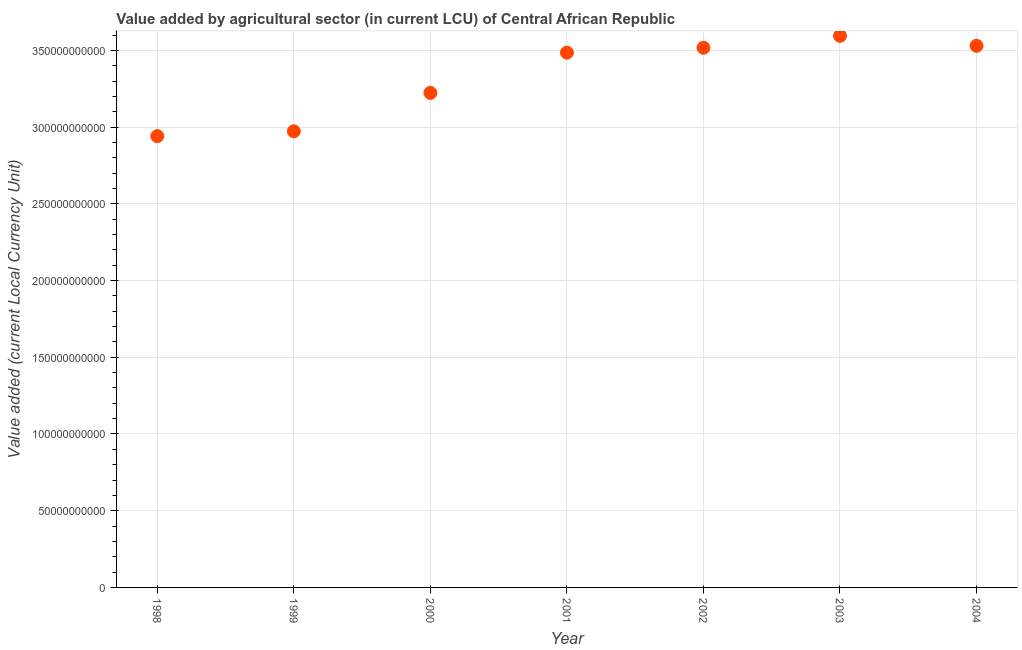What is the value added by agriculture sector in 1998?
Your answer should be compact. 2.94e+11. Across all years, what is the maximum value added by agriculture sector?
Ensure brevity in your answer.  3.59e+11. Across all years, what is the minimum value added by agriculture sector?
Your answer should be very brief. 2.94e+11. In which year was the value added by agriculture sector maximum?
Make the answer very short. 2003. What is the sum of the value added by agriculture sector?
Keep it short and to the point. 2.33e+12. What is the difference between the value added by agriculture sector in 2002 and 2003?
Ensure brevity in your answer.  -7.78e+09. What is the average value added by agriculture sector per year?
Your response must be concise. 3.32e+11. What is the median value added by agriculture sector?
Give a very brief answer. 3.49e+11. In how many years, is the value added by agriculture sector greater than 20000000000 LCU?
Your answer should be compact. 7. What is the ratio of the value added by agriculture sector in 1998 to that in 2003?
Give a very brief answer. 0.82. Is the difference between the value added by agriculture sector in 2000 and 2004 greater than the difference between any two years?
Give a very brief answer. No. What is the difference between the highest and the second highest value added by agriculture sector?
Ensure brevity in your answer.  6.50e+09. What is the difference between the highest and the lowest value added by agriculture sector?
Give a very brief answer. 6.54e+1. In how many years, is the value added by agriculture sector greater than the average value added by agriculture sector taken over all years?
Give a very brief answer. 4. How many years are there in the graph?
Provide a succinct answer. 7. What is the difference between two consecutive major ticks on the Y-axis?
Your response must be concise. 5.00e+1. Does the graph contain any zero values?
Offer a terse response. No. What is the title of the graph?
Give a very brief answer. Value added by agricultural sector (in current LCU) of Central African Republic. What is the label or title of the Y-axis?
Provide a short and direct response. Value added (current Local Currency Unit). What is the Value added (current Local Currency Unit) in 1998?
Keep it short and to the point. 2.94e+11. What is the Value added (current Local Currency Unit) in 1999?
Ensure brevity in your answer.  2.97e+11. What is the Value added (current Local Currency Unit) in 2000?
Keep it short and to the point. 3.22e+11. What is the Value added (current Local Currency Unit) in 2001?
Your answer should be very brief. 3.49e+11. What is the Value added (current Local Currency Unit) in 2002?
Give a very brief answer. 3.52e+11. What is the Value added (current Local Currency Unit) in 2003?
Provide a short and direct response. 3.59e+11. What is the Value added (current Local Currency Unit) in 2004?
Ensure brevity in your answer.  3.53e+11. What is the difference between the Value added (current Local Currency Unit) in 1998 and 1999?
Your answer should be compact. -3.16e+09. What is the difference between the Value added (current Local Currency Unit) in 1998 and 2000?
Give a very brief answer. -2.82e+1. What is the difference between the Value added (current Local Currency Unit) in 1998 and 2001?
Your answer should be very brief. -5.44e+1. What is the difference between the Value added (current Local Currency Unit) in 1998 and 2002?
Your answer should be very brief. -5.76e+1. What is the difference between the Value added (current Local Currency Unit) in 1998 and 2003?
Provide a short and direct response. -6.54e+1. What is the difference between the Value added (current Local Currency Unit) in 1998 and 2004?
Provide a succinct answer. -5.89e+1. What is the difference between the Value added (current Local Currency Unit) in 1999 and 2000?
Keep it short and to the point. -2.50e+1. What is the difference between the Value added (current Local Currency Unit) in 1999 and 2001?
Ensure brevity in your answer.  -5.13e+1. What is the difference between the Value added (current Local Currency Unit) in 1999 and 2002?
Your response must be concise. -5.44e+1. What is the difference between the Value added (current Local Currency Unit) in 1999 and 2003?
Your answer should be compact. -6.22e+1. What is the difference between the Value added (current Local Currency Unit) in 1999 and 2004?
Ensure brevity in your answer.  -5.57e+1. What is the difference between the Value added (current Local Currency Unit) in 2000 and 2001?
Offer a terse response. -2.62e+1. What is the difference between the Value added (current Local Currency Unit) in 2000 and 2002?
Your answer should be compact. -2.94e+1. What is the difference between the Value added (current Local Currency Unit) in 2000 and 2003?
Your answer should be compact. -3.72e+1. What is the difference between the Value added (current Local Currency Unit) in 2000 and 2004?
Provide a short and direct response. -3.07e+1. What is the difference between the Value added (current Local Currency Unit) in 2001 and 2002?
Your response must be concise. -3.17e+09. What is the difference between the Value added (current Local Currency Unit) in 2001 and 2003?
Provide a succinct answer. -1.10e+1. What is the difference between the Value added (current Local Currency Unit) in 2001 and 2004?
Keep it short and to the point. -4.45e+09. What is the difference between the Value added (current Local Currency Unit) in 2002 and 2003?
Make the answer very short. -7.78e+09. What is the difference between the Value added (current Local Currency Unit) in 2002 and 2004?
Your response must be concise. -1.28e+09. What is the difference between the Value added (current Local Currency Unit) in 2003 and 2004?
Provide a short and direct response. 6.50e+09. What is the ratio of the Value added (current Local Currency Unit) in 1998 to that in 1999?
Offer a terse response. 0.99. What is the ratio of the Value added (current Local Currency Unit) in 1998 to that in 2001?
Offer a terse response. 0.84. What is the ratio of the Value added (current Local Currency Unit) in 1998 to that in 2002?
Provide a succinct answer. 0.84. What is the ratio of the Value added (current Local Currency Unit) in 1998 to that in 2003?
Offer a terse response. 0.82. What is the ratio of the Value added (current Local Currency Unit) in 1998 to that in 2004?
Provide a short and direct response. 0.83. What is the ratio of the Value added (current Local Currency Unit) in 1999 to that in 2000?
Keep it short and to the point. 0.92. What is the ratio of the Value added (current Local Currency Unit) in 1999 to that in 2001?
Provide a short and direct response. 0.85. What is the ratio of the Value added (current Local Currency Unit) in 1999 to that in 2002?
Ensure brevity in your answer.  0.84. What is the ratio of the Value added (current Local Currency Unit) in 1999 to that in 2003?
Give a very brief answer. 0.83. What is the ratio of the Value added (current Local Currency Unit) in 1999 to that in 2004?
Give a very brief answer. 0.84. What is the ratio of the Value added (current Local Currency Unit) in 2000 to that in 2001?
Offer a terse response. 0.93. What is the ratio of the Value added (current Local Currency Unit) in 2000 to that in 2002?
Provide a short and direct response. 0.92. What is the ratio of the Value added (current Local Currency Unit) in 2000 to that in 2003?
Your response must be concise. 0.9. What is the ratio of the Value added (current Local Currency Unit) in 2000 to that in 2004?
Offer a terse response. 0.91. What is the ratio of the Value added (current Local Currency Unit) in 2001 to that in 2004?
Keep it short and to the point. 0.99. What is the ratio of the Value added (current Local Currency Unit) in 2002 to that in 2004?
Make the answer very short. 1. What is the ratio of the Value added (current Local Currency Unit) in 2003 to that in 2004?
Your answer should be compact. 1.02. 